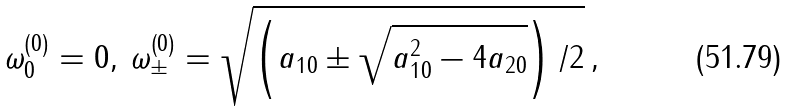Convert formula to latex. <formula><loc_0><loc_0><loc_500><loc_500>\omega _ { 0 } ^ { \left ( 0 \right ) } = 0 , \, \omega _ { \pm } ^ { \left ( 0 \right ) } = \sqrt { \left ( a _ { 1 0 } \pm \sqrt { a _ { 1 0 } ^ { 2 } - 4 a _ { 2 0 } } \right ) / 2 } \, ,</formula> 